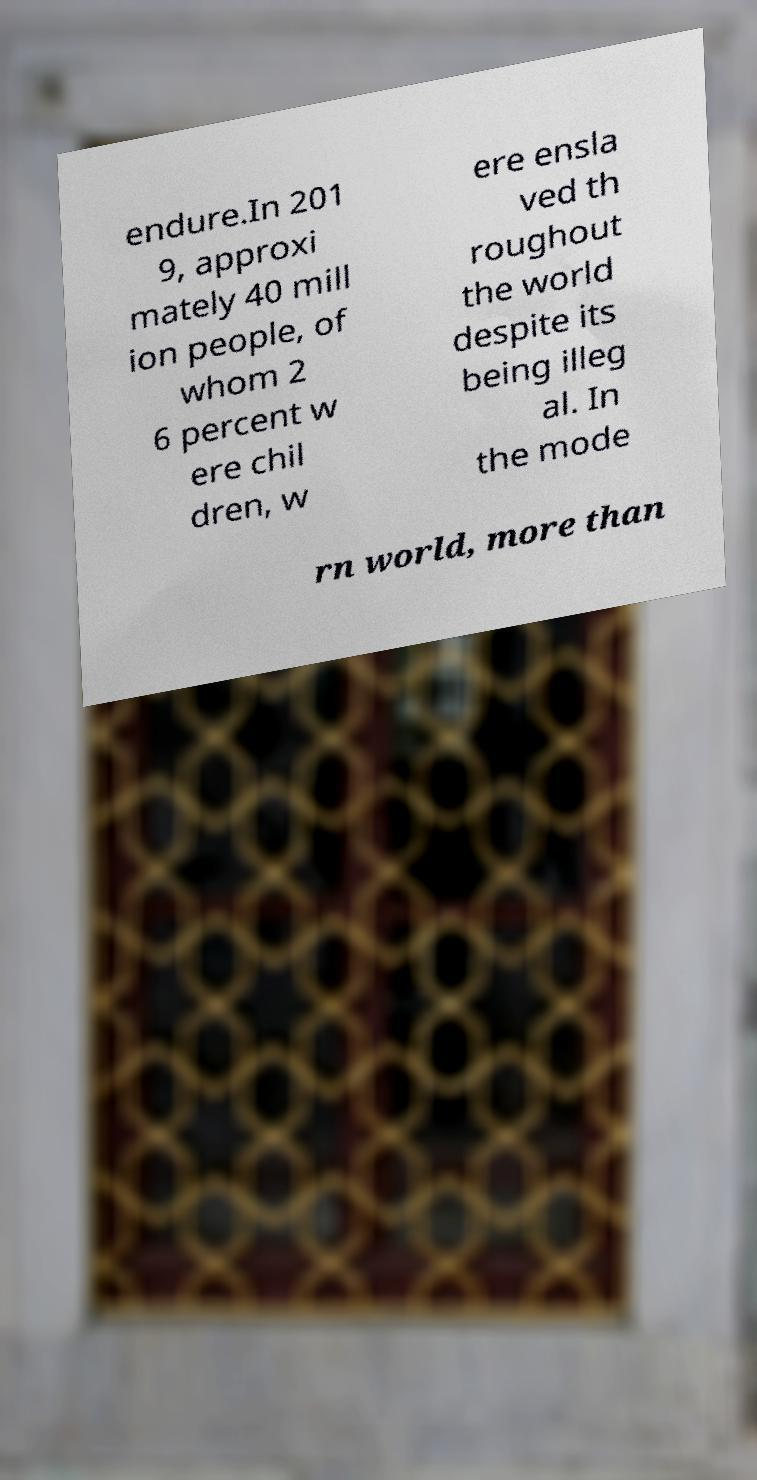Could you assist in decoding the text presented in this image and type it out clearly? endure.In 201 9, approxi mately 40 mill ion people, of whom 2 6 percent w ere chil dren, w ere ensla ved th roughout the world despite its being illeg al. In the mode rn world, more than 